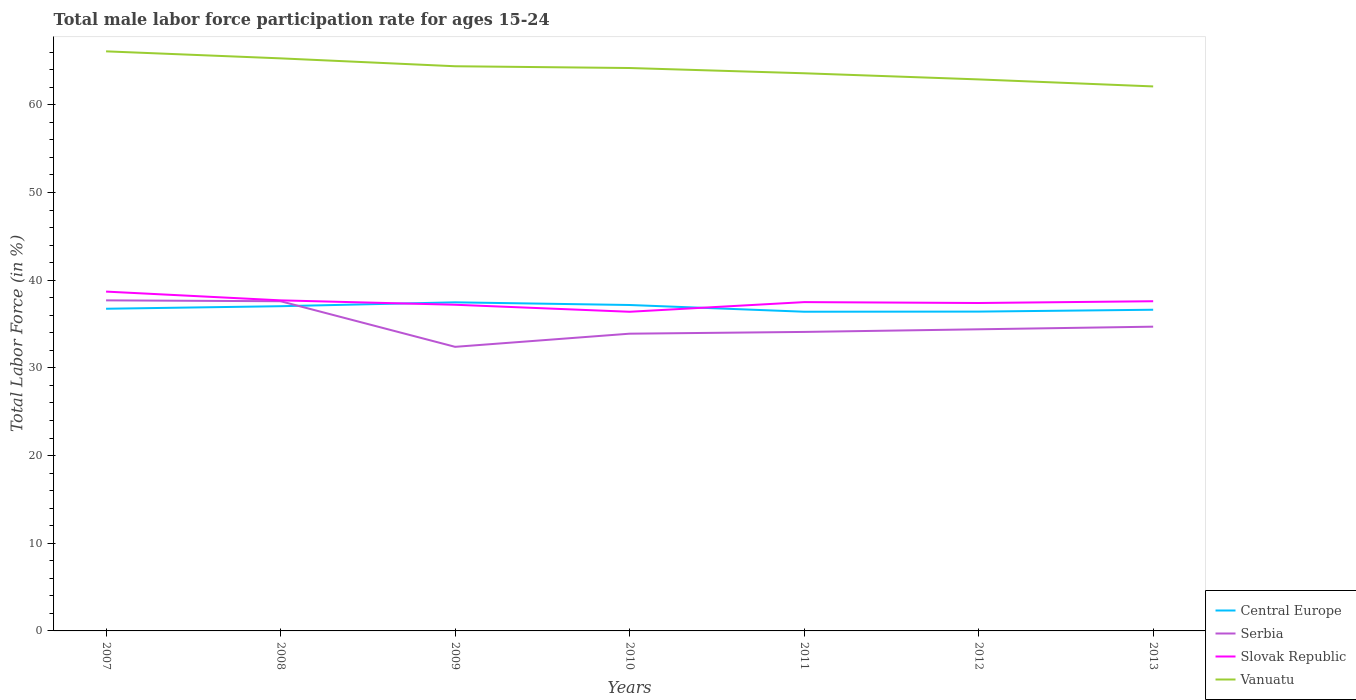How many different coloured lines are there?
Offer a very short reply. 4. Is the number of lines equal to the number of legend labels?
Offer a terse response. Yes. Across all years, what is the maximum male labor force participation rate in Slovak Republic?
Give a very brief answer. 36.4. In which year was the male labor force participation rate in Serbia maximum?
Keep it short and to the point. 2009. What is the total male labor force participation rate in Serbia in the graph?
Provide a short and direct response. 2.9. What is the difference between the highest and the second highest male labor force participation rate in Slovak Republic?
Provide a succinct answer. 2.3. Is the male labor force participation rate in Serbia strictly greater than the male labor force participation rate in Vanuatu over the years?
Your response must be concise. Yes. How many lines are there?
Offer a terse response. 4. How many years are there in the graph?
Provide a short and direct response. 7. What is the difference between two consecutive major ticks on the Y-axis?
Offer a terse response. 10. Are the values on the major ticks of Y-axis written in scientific E-notation?
Your response must be concise. No. Does the graph contain any zero values?
Your answer should be very brief. No. Does the graph contain grids?
Offer a terse response. No. How are the legend labels stacked?
Provide a short and direct response. Vertical. What is the title of the graph?
Your answer should be very brief. Total male labor force participation rate for ages 15-24. Does "Dominican Republic" appear as one of the legend labels in the graph?
Your answer should be very brief. No. What is the label or title of the X-axis?
Your response must be concise. Years. What is the label or title of the Y-axis?
Your answer should be very brief. Total Labor Force (in %). What is the Total Labor Force (in %) in Central Europe in 2007?
Your response must be concise. 36.74. What is the Total Labor Force (in %) of Serbia in 2007?
Offer a very short reply. 37.7. What is the Total Labor Force (in %) in Slovak Republic in 2007?
Make the answer very short. 38.7. What is the Total Labor Force (in %) in Vanuatu in 2007?
Your response must be concise. 66.1. What is the Total Labor Force (in %) in Central Europe in 2008?
Your answer should be very brief. 37.03. What is the Total Labor Force (in %) of Serbia in 2008?
Your response must be concise. 37.6. What is the Total Labor Force (in %) of Slovak Republic in 2008?
Provide a succinct answer. 37.7. What is the Total Labor Force (in %) of Vanuatu in 2008?
Ensure brevity in your answer.  65.3. What is the Total Labor Force (in %) in Central Europe in 2009?
Offer a terse response. 37.48. What is the Total Labor Force (in %) of Serbia in 2009?
Offer a terse response. 32.4. What is the Total Labor Force (in %) of Slovak Republic in 2009?
Your answer should be compact. 37.2. What is the Total Labor Force (in %) of Vanuatu in 2009?
Provide a succinct answer. 64.4. What is the Total Labor Force (in %) in Central Europe in 2010?
Offer a terse response. 37.17. What is the Total Labor Force (in %) in Serbia in 2010?
Offer a very short reply. 33.9. What is the Total Labor Force (in %) of Slovak Republic in 2010?
Keep it short and to the point. 36.4. What is the Total Labor Force (in %) in Vanuatu in 2010?
Provide a succinct answer. 64.2. What is the Total Labor Force (in %) in Central Europe in 2011?
Keep it short and to the point. 36.4. What is the Total Labor Force (in %) in Serbia in 2011?
Offer a very short reply. 34.1. What is the Total Labor Force (in %) in Slovak Republic in 2011?
Provide a succinct answer. 37.5. What is the Total Labor Force (in %) of Vanuatu in 2011?
Provide a succinct answer. 63.6. What is the Total Labor Force (in %) in Central Europe in 2012?
Give a very brief answer. 36.42. What is the Total Labor Force (in %) in Serbia in 2012?
Provide a short and direct response. 34.4. What is the Total Labor Force (in %) in Slovak Republic in 2012?
Provide a short and direct response. 37.4. What is the Total Labor Force (in %) in Vanuatu in 2012?
Make the answer very short. 62.9. What is the Total Labor Force (in %) of Central Europe in 2013?
Keep it short and to the point. 36.63. What is the Total Labor Force (in %) in Serbia in 2013?
Offer a terse response. 34.7. What is the Total Labor Force (in %) of Slovak Republic in 2013?
Your answer should be very brief. 37.6. What is the Total Labor Force (in %) of Vanuatu in 2013?
Keep it short and to the point. 62.1. Across all years, what is the maximum Total Labor Force (in %) in Central Europe?
Provide a short and direct response. 37.48. Across all years, what is the maximum Total Labor Force (in %) of Serbia?
Make the answer very short. 37.7. Across all years, what is the maximum Total Labor Force (in %) in Slovak Republic?
Make the answer very short. 38.7. Across all years, what is the maximum Total Labor Force (in %) in Vanuatu?
Your answer should be very brief. 66.1. Across all years, what is the minimum Total Labor Force (in %) in Central Europe?
Provide a succinct answer. 36.4. Across all years, what is the minimum Total Labor Force (in %) in Serbia?
Provide a succinct answer. 32.4. Across all years, what is the minimum Total Labor Force (in %) of Slovak Republic?
Offer a very short reply. 36.4. Across all years, what is the minimum Total Labor Force (in %) of Vanuatu?
Provide a succinct answer. 62.1. What is the total Total Labor Force (in %) of Central Europe in the graph?
Offer a terse response. 257.88. What is the total Total Labor Force (in %) in Serbia in the graph?
Make the answer very short. 244.8. What is the total Total Labor Force (in %) of Slovak Republic in the graph?
Provide a short and direct response. 262.5. What is the total Total Labor Force (in %) in Vanuatu in the graph?
Keep it short and to the point. 448.6. What is the difference between the Total Labor Force (in %) of Central Europe in 2007 and that in 2008?
Ensure brevity in your answer.  -0.29. What is the difference between the Total Labor Force (in %) in Slovak Republic in 2007 and that in 2008?
Give a very brief answer. 1. What is the difference between the Total Labor Force (in %) in Vanuatu in 2007 and that in 2008?
Provide a succinct answer. 0.8. What is the difference between the Total Labor Force (in %) in Central Europe in 2007 and that in 2009?
Your response must be concise. -0.73. What is the difference between the Total Labor Force (in %) of Serbia in 2007 and that in 2009?
Offer a very short reply. 5.3. What is the difference between the Total Labor Force (in %) in Slovak Republic in 2007 and that in 2009?
Ensure brevity in your answer.  1.5. What is the difference between the Total Labor Force (in %) in Central Europe in 2007 and that in 2010?
Your answer should be compact. -0.43. What is the difference between the Total Labor Force (in %) of Slovak Republic in 2007 and that in 2010?
Provide a succinct answer. 2.3. What is the difference between the Total Labor Force (in %) in Central Europe in 2007 and that in 2011?
Keep it short and to the point. 0.34. What is the difference between the Total Labor Force (in %) in Vanuatu in 2007 and that in 2011?
Your response must be concise. 2.5. What is the difference between the Total Labor Force (in %) in Central Europe in 2007 and that in 2012?
Keep it short and to the point. 0.32. What is the difference between the Total Labor Force (in %) in Vanuatu in 2007 and that in 2012?
Provide a succinct answer. 3.2. What is the difference between the Total Labor Force (in %) of Central Europe in 2007 and that in 2013?
Your response must be concise. 0.11. What is the difference between the Total Labor Force (in %) in Central Europe in 2008 and that in 2009?
Your answer should be compact. -0.44. What is the difference between the Total Labor Force (in %) of Slovak Republic in 2008 and that in 2009?
Your answer should be very brief. 0.5. What is the difference between the Total Labor Force (in %) in Vanuatu in 2008 and that in 2009?
Provide a short and direct response. 0.9. What is the difference between the Total Labor Force (in %) of Central Europe in 2008 and that in 2010?
Your response must be concise. -0.14. What is the difference between the Total Labor Force (in %) in Serbia in 2008 and that in 2010?
Offer a very short reply. 3.7. What is the difference between the Total Labor Force (in %) of Slovak Republic in 2008 and that in 2010?
Make the answer very short. 1.3. What is the difference between the Total Labor Force (in %) in Central Europe in 2008 and that in 2011?
Provide a succinct answer. 0.63. What is the difference between the Total Labor Force (in %) of Serbia in 2008 and that in 2011?
Provide a short and direct response. 3.5. What is the difference between the Total Labor Force (in %) of Slovak Republic in 2008 and that in 2011?
Ensure brevity in your answer.  0.2. What is the difference between the Total Labor Force (in %) of Vanuatu in 2008 and that in 2011?
Your response must be concise. 1.7. What is the difference between the Total Labor Force (in %) in Central Europe in 2008 and that in 2012?
Provide a succinct answer. 0.61. What is the difference between the Total Labor Force (in %) in Serbia in 2008 and that in 2012?
Offer a terse response. 3.2. What is the difference between the Total Labor Force (in %) in Central Europe in 2008 and that in 2013?
Make the answer very short. 0.4. What is the difference between the Total Labor Force (in %) in Serbia in 2008 and that in 2013?
Provide a succinct answer. 2.9. What is the difference between the Total Labor Force (in %) in Vanuatu in 2008 and that in 2013?
Give a very brief answer. 3.2. What is the difference between the Total Labor Force (in %) in Central Europe in 2009 and that in 2010?
Offer a terse response. 0.31. What is the difference between the Total Labor Force (in %) of Vanuatu in 2009 and that in 2010?
Your answer should be compact. 0.2. What is the difference between the Total Labor Force (in %) of Central Europe in 2009 and that in 2011?
Give a very brief answer. 1.07. What is the difference between the Total Labor Force (in %) in Slovak Republic in 2009 and that in 2011?
Your answer should be very brief. -0.3. What is the difference between the Total Labor Force (in %) of Vanuatu in 2009 and that in 2011?
Your response must be concise. 0.8. What is the difference between the Total Labor Force (in %) of Central Europe in 2009 and that in 2012?
Your answer should be compact. 1.06. What is the difference between the Total Labor Force (in %) of Central Europe in 2009 and that in 2013?
Your answer should be very brief. 0.84. What is the difference between the Total Labor Force (in %) in Serbia in 2009 and that in 2013?
Provide a succinct answer. -2.3. What is the difference between the Total Labor Force (in %) in Slovak Republic in 2009 and that in 2013?
Your response must be concise. -0.4. What is the difference between the Total Labor Force (in %) in Central Europe in 2010 and that in 2011?
Your answer should be compact. 0.77. What is the difference between the Total Labor Force (in %) in Serbia in 2010 and that in 2011?
Offer a very short reply. -0.2. What is the difference between the Total Labor Force (in %) in Central Europe in 2010 and that in 2012?
Your answer should be very brief. 0.75. What is the difference between the Total Labor Force (in %) in Serbia in 2010 and that in 2012?
Keep it short and to the point. -0.5. What is the difference between the Total Labor Force (in %) in Central Europe in 2010 and that in 2013?
Your response must be concise. 0.54. What is the difference between the Total Labor Force (in %) in Serbia in 2010 and that in 2013?
Provide a succinct answer. -0.8. What is the difference between the Total Labor Force (in %) of Vanuatu in 2010 and that in 2013?
Give a very brief answer. 2.1. What is the difference between the Total Labor Force (in %) of Central Europe in 2011 and that in 2012?
Keep it short and to the point. -0.01. What is the difference between the Total Labor Force (in %) in Serbia in 2011 and that in 2012?
Make the answer very short. -0.3. What is the difference between the Total Labor Force (in %) in Slovak Republic in 2011 and that in 2012?
Ensure brevity in your answer.  0.1. What is the difference between the Total Labor Force (in %) of Vanuatu in 2011 and that in 2012?
Ensure brevity in your answer.  0.7. What is the difference between the Total Labor Force (in %) of Central Europe in 2011 and that in 2013?
Offer a terse response. -0.23. What is the difference between the Total Labor Force (in %) of Central Europe in 2012 and that in 2013?
Offer a very short reply. -0.21. What is the difference between the Total Labor Force (in %) in Slovak Republic in 2012 and that in 2013?
Offer a very short reply. -0.2. What is the difference between the Total Labor Force (in %) in Vanuatu in 2012 and that in 2013?
Offer a terse response. 0.8. What is the difference between the Total Labor Force (in %) in Central Europe in 2007 and the Total Labor Force (in %) in Serbia in 2008?
Ensure brevity in your answer.  -0.86. What is the difference between the Total Labor Force (in %) in Central Europe in 2007 and the Total Labor Force (in %) in Slovak Republic in 2008?
Your answer should be very brief. -0.96. What is the difference between the Total Labor Force (in %) in Central Europe in 2007 and the Total Labor Force (in %) in Vanuatu in 2008?
Keep it short and to the point. -28.56. What is the difference between the Total Labor Force (in %) in Serbia in 2007 and the Total Labor Force (in %) in Vanuatu in 2008?
Provide a succinct answer. -27.6. What is the difference between the Total Labor Force (in %) in Slovak Republic in 2007 and the Total Labor Force (in %) in Vanuatu in 2008?
Make the answer very short. -26.6. What is the difference between the Total Labor Force (in %) in Central Europe in 2007 and the Total Labor Force (in %) in Serbia in 2009?
Keep it short and to the point. 4.34. What is the difference between the Total Labor Force (in %) of Central Europe in 2007 and the Total Labor Force (in %) of Slovak Republic in 2009?
Give a very brief answer. -0.46. What is the difference between the Total Labor Force (in %) in Central Europe in 2007 and the Total Labor Force (in %) in Vanuatu in 2009?
Offer a terse response. -27.66. What is the difference between the Total Labor Force (in %) of Serbia in 2007 and the Total Labor Force (in %) of Slovak Republic in 2009?
Keep it short and to the point. 0.5. What is the difference between the Total Labor Force (in %) of Serbia in 2007 and the Total Labor Force (in %) of Vanuatu in 2009?
Offer a very short reply. -26.7. What is the difference between the Total Labor Force (in %) in Slovak Republic in 2007 and the Total Labor Force (in %) in Vanuatu in 2009?
Offer a terse response. -25.7. What is the difference between the Total Labor Force (in %) of Central Europe in 2007 and the Total Labor Force (in %) of Serbia in 2010?
Your answer should be very brief. 2.84. What is the difference between the Total Labor Force (in %) in Central Europe in 2007 and the Total Labor Force (in %) in Slovak Republic in 2010?
Give a very brief answer. 0.34. What is the difference between the Total Labor Force (in %) of Central Europe in 2007 and the Total Labor Force (in %) of Vanuatu in 2010?
Provide a succinct answer. -27.46. What is the difference between the Total Labor Force (in %) in Serbia in 2007 and the Total Labor Force (in %) in Slovak Republic in 2010?
Provide a succinct answer. 1.3. What is the difference between the Total Labor Force (in %) of Serbia in 2007 and the Total Labor Force (in %) of Vanuatu in 2010?
Offer a very short reply. -26.5. What is the difference between the Total Labor Force (in %) of Slovak Republic in 2007 and the Total Labor Force (in %) of Vanuatu in 2010?
Ensure brevity in your answer.  -25.5. What is the difference between the Total Labor Force (in %) of Central Europe in 2007 and the Total Labor Force (in %) of Serbia in 2011?
Give a very brief answer. 2.64. What is the difference between the Total Labor Force (in %) of Central Europe in 2007 and the Total Labor Force (in %) of Slovak Republic in 2011?
Make the answer very short. -0.76. What is the difference between the Total Labor Force (in %) in Central Europe in 2007 and the Total Labor Force (in %) in Vanuatu in 2011?
Your answer should be very brief. -26.86. What is the difference between the Total Labor Force (in %) in Serbia in 2007 and the Total Labor Force (in %) in Vanuatu in 2011?
Provide a short and direct response. -25.9. What is the difference between the Total Labor Force (in %) in Slovak Republic in 2007 and the Total Labor Force (in %) in Vanuatu in 2011?
Offer a very short reply. -24.9. What is the difference between the Total Labor Force (in %) of Central Europe in 2007 and the Total Labor Force (in %) of Serbia in 2012?
Your response must be concise. 2.34. What is the difference between the Total Labor Force (in %) of Central Europe in 2007 and the Total Labor Force (in %) of Slovak Republic in 2012?
Provide a succinct answer. -0.66. What is the difference between the Total Labor Force (in %) of Central Europe in 2007 and the Total Labor Force (in %) of Vanuatu in 2012?
Ensure brevity in your answer.  -26.16. What is the difference between the Total Labor Force (in %) of Serbia in 2007 and the Total Labor Force (in %) of Vanuatu in 2012?
Give a very brief answer. -25.2. What is the difference between the Total Labor Force (in %) in Slovak Republic in 2007 and the Total Labor Force (in %) in Vanuatu in 2012?
Offer a terse response. -24.2. What is the difference between the Total Labor Force (in %) in Central Europe in 2007 and the Total Labor Force (in %) in Serbia in 2013?
Provide a short and direct response. 2.04. What is the difference between the Total Labor Force (in %) of Central Europe in 2007 and the Total Labor Force (in %) of Slovak Republic in 2013?
Make the answer very short. -0.86. What is the difference between the Total Labor Force (in %) of Central Europe in 2007 and the Total Labor Force (in %) of Vanuatu in 2013?
Offer a terse response. -25.36. What is the difference between the Total Labor Force (in %) in Serbia in 2007 and the Total Labor Force (in %) in Slovak Republic in 2013?
Keep it short and to the point. 0.1. What is the difference between the Total Labor Force (in %) in Serbia in 2007 and the Total Labor Force (in %) in Vanuatu in 2013?
Keep it short and to the point. -24.4. What is the difference between the Total Labor Force (in %) in Slovak Republic in 2007 and the Total Labor Force (in %) in Vanuatu in 2013?
Provide a short and direct response. -23.4. What is the difference between the Total Labor Force (in %) of Central Europe in 2008 and the Total Labor Force (in %) of Serbia in 2009?
Offer a very short reply. 4.63. What is the difference between the Total Labor Force (in %) in Central Europe in 2008 and the Total Labor Force (in %) in Slovak Republic in 2009?
Provide a short and direct response. -0.17. What is the difference between the Total Labor Force (in %) of Central Europe in 2008 and the Total Labor Force (in %) of Vanuatu in 2009?
Offer a terse response. -27.37. What is the difference between the Total Labor Force (in %) in Serbia in 2008 and the Total Labor Force (in %) in Slovak Republic in 2009?
Make the answer very short. 0.4. What is the difference between the Total Labor Force (in %) in Serbia in 2008 and the Total Labor Force (in %) in Vanuatu in 2009?
Your answer should be very brief. -26.8. What is the difference between the Total Labor Force (in %) in Slovak Republic in 2008 and the Total Labor Force (in %) in Vanuatu in 2009?
Your response must be concise. -26.7. What is the difference between the Total Labor Force (in %) in Central Europe in 2008 and the Total Labor Force (in %) in Serbia in 2010?
Offer a very short reply. 3.13. What is the difference between the Total Labor Force (in %) in Central Europe in 2008 and the Total Labor Force (in %) in Slovak Republic in 2010?
Offer a terse response. 0.63. What is the difference between the Total Labor Force (in %) of Central Europe in 2008 and the Total Labor Force (in %) of Vanuatu in 2010?
Your answer should be very brief. -27.17. What is the difference between the Total Labor Force (in %) of Serbia in 2008 and the Total Labor Force (in %) of Vanuatu in 2010?
Provide a short and direct response. -26.6. What is the difference between the Total Labor Force (in %) of Slovak Republic in 2008 and the Total Labor Force (in %) of Vanuatu in 2010?
Keep it short and to the point. -26.5. What is the difference between the Total Labor Force (in %) in Central Europe in 2008 and the Total Labor Force (in %) in Serbia in 2011?
Your answer should be very brief. 2.93. What is the difference between the Total Labor Force (in %) of Central Europe in 2008 and the Total Labor Force (in %) of Slovak Republic in 2011?
Ensure brevity in your answer.  -0.47. What is the difference between the Total Labor Force (in %) in Central Europe in 2008 and the Total Labor Force (in %) in Vanuatu in 2011?
Your response must be concise. -26.57. What is the difference between the Total Labor Force (in %) of Serbia in 2008 and the Total Labor Force (in %) of Vanuatu in 2011?
Ensure brevity in your answer.  -26. What is the difference between the Total Labor Force (in %) in Slovak Republic in 2008 and the Total Labor Force (in %) in Vanuatu in 2011?
Make the answer very short. -25.9. What is the difference between the Total Labor Force (in %) of Central Europe in 2008 and the Total Labor Force (in %) of Serbia in 2012?
Keep it short and to the point. 2.63. What is the difference between the Total Labor Force (in %) of Central Europe in 2008 and the Total Labor Force (in %) of Slovak Republic in 2012?
Offer a terse response. -0.37. What is the difference between the Total Labor Force (in %) in Central Europe in 2008 and the Total Labor Force (in %) in Vanuatu in 2012?
Provide a short and direct response. -25.87. What is the difference between the Total Labor Force (in %) in Serbia in 2008 and the Total Labor Force (in %) in Vanuatu in 2012?
Your answer should be compact. -25.3. What is the difference between the Total Labor Force (in %) in Slovak Republic in 2008 and the Total Labor Force (in %) in Vanuatu in 2012?
Give a very brief answer. -25.2. What is the difference between the Total Labor Force (in %) in Central Europe in 2008 and the Total Labor Force (in %) in Serbia in 2013?
Provide a short and direct response. 2.33. What is the difference between the Total Labor Force (in %) in Central Europe in 2008 and the Total Labor Force (in %) in Slovak Republic in 2013?
Keep it short and to the point. -0.57. What is the difference between the Total Labor Force (in %) of Central Europe in 2008 and the Total Labor Force (in %) of Vanuatu in 2013?
Provide a succinct answer. -25.07. What is the difference between the Total Labor Force (in %) in Serbia in 2008 and the Total Labor Force (in %) in Slovak Republic in 2013?
Keep it short and to the point. 0. What is the difference between the Total Labor Force (in %) in Serbia in 2008 and the Total Labor Force (in %) in Vanuatu in 2013?
Your answer should be compact. -24.5. What is the difference between the Total Labor Force (in %) in Slovak Republic in 2008 and the Total Labor Force (in %) in Vanuatu in 2013?
Ensure brevity in your answer.  -24.4. What is the difference between the Total Labor Force (in %) in Central Europe in 2009 and the Total Labor Force (in %) in Serbia in 2010?
Ensure brevity in your answer.  3.58. What is the difference between the Total Labor Force (in %) of Central Europe in 2009 and the Total Labor Force (in %) of Slovak Republic in 2010?
Offer a very short reply. 1.08. What is the difference between the Total Labor Force (in %) of Central Europe in 2009 and the Total Labor Force (in %) of Vanuatu in 2010?
Keep it short and to the point. -26.72. What is the difference between the Total Labor Force (in %) in Serbia in 2009 and the Total Labor Force (in %) in Vanuatu in 2010?
Give a very brief answer. -31.8. What is the difference between the Total Labor Force (in %) of Slovak Republic in 2009 and the Total Labor Force (in %) of Vanuatu in 2010?
Your response must be concise. -27. What is the difference between the Total Labor Force (in %) in Central Europe in 2009 and the Total Labor Force (in %) in Serbia in 2011?
Make the answer very short. 3.38. What is the difference between the Total Labor Force (in %) in Central Europe in 2009 and the Total Labor Force (in %) in Slovak Republic in 2011?
Offer a terse response. -0.02. What is the difference between the Total Labor Force (in %) in Central Europe in 2009 and the Total Labor Force (in %) in Vanuatu in 2011?
Your answer should be very brief. -26.12. What is the difference between the Total Labor Force (in %) of Serbia in 2009 and the Total Labor Force (in %) of Slovak Republic in 2011?
Give a very brief answer. -5.1. What is the difference between the Total Labor Force (in %) of Serbia in 2009 and the Total Labor Force (in %) of Vanuatu in 2011?
Offer a terse response. -31.2. What is the difference between the Total Labor Force (in %) of Slovak Republic in 2009 and the Total Labor Force (in %) of Vanuatu in 2011?
Your response must be concise. -26.4. What is the difference between the Total Labor Force (in %) of Central Europe in 2009 and the Total Labor Force (in %) of Serbia in 2012?
Make the answer very short. 3.08. What is the difference between the Total Labor Force (in %) of Central Europe in 2009 and the Total Labor Force (in %) of Slovak Republic in 2012?
Your response must be concise. 0.08. What is the difference between the Total Labor Force (in %) of Central Europe in 2009 and the Total Labor Force (in %) of Vanuatu in 2012?
Offer a very short reply. -25.42. What is the difference between the Total Labor Force (in %) in Serbia in 2009 and the Total Labor Force (in %) in Slovak Republic in 2012?
Make the answer very short. -5. What is the difference between the Total Labor Force (in %) of Serbia in 2009 and the Total Labor Force (in %) of Vanuatu in 2012?
Keep it short and to the point. -30.5. What is the difference between the Total Labor Force (in %) in Slovak Republic in 2009 and the Total Labor Force (in %) in Vanuatu in 2012?
Your answer should be very brief. -25.7. What is the difference between the Total Labor Force (in %) in Central Europe in 2009 and the Total Labor Force (in %) in Serbia in 2013?
Offer a terse response. 2.78. What is the difference between the Total Labor Force (in %) of Central Europe in 2009 and the Total Labor Force (in %) of Slovak Republic in 2013?
Make the answer very short. -0.12. What is the difference between the Total Labor Force (in %) of Central Europe in 2009 and the Total Labor Force (in %) of Vanuatu in 2013?
Provide a short and direct response. -24.62. What is the difference between the Total Labor Force (in %) in Serbia in 2009 and the Total Labor Force (in %) in Slovak Republic in 2013?
Offer a very short reply. -5.2. What is the difference between the Total Labor Force (in %) of Serbia in 2009 and the Total Labor Force (in %) of Vanuatu in 2013?
Your answer should be compact. -29.7. What is the difference between the Total Labor Force (in %) of Slovak Republic in 2009 and the Total Labor Force (in %) of Vanuatu in 2013?
Offer a terse response. -24.9. What is the difference between the Total Labor Force (in %) of Central Europe in 2010 and the Total Labor Force (in %) of Serbia in 2011?
Your answer should be compact. 3.07. What is the difference between the Total Labor Force (in %) of Central Europe in 2010 and the Total Labor Force (in %) of Slovak Republic in 2011?
Provide a succinct answer. -0.33. What is the difference between the Total Labor Force (in %) in Central Europe in 2010 and the Total Labor Force (in %) in Vanuatu in 2011?
Keep it short and to the point. -26.43. What is the difference between the Total Labor Force (in %) of Serbia in 2010 and the Total Labor Force (in %) of Slovak Republic in 2011?
Provide a short and direct response. -3.6. What is the difference between the Total Labor Force (in %) in Serbia in 2010 and the Total Labor Force (in %) in Vanuatu in 2011?
Offer a terse response. -29.7. What is the difference between the Total Labor Force (in %) of Slovak Republic in 2010 and the Total Labor Force (in %) of Vanuatu in 2011?
Ensure brevity in your answer.  -27.2. What is the difference between the Total Labor Force (in %) in Central Europe in 2010 and the Total Labor Force (in %) in Serbia in 2012?
Keep it short and to the point. 2.77. What is the difference between the Total Labor Force (in %) in Central Europe in 2010 and the Total Labor Force (in %) in Slovak Republic in 2012?
Make the answer very short. -0.23. What is the difference between the Total Labor Force (in %) of Central Europe in 2010 and the Total Labor Force (in %) of Vanuatu in 2012?
Give a very brief answer. -25.73. What is the difference between the Total Labor Force (in %) in Serbia in 2010 and the Total Labor Force (in %) in Slovak Republic in 2012?
Offer a terse response. -3.5. What is the difference between the Total Labor Force (in %) of Slovak Republic in 2010 and the Total Labor Force (in %) of Vanuatu in 2012?
Make the answer very short. -26.5. What is the difference between the Total Labor Force (in %) in Central Europe in 2010 and the Total Labor Force (in %) in Serbia in 2013?
Give a very brief answer. 2.47. What is the difference between the Total Labor Force (in %) in Central Europe in 2010 and the Total Labor Force (in %) in Slovak Republic in 2013?
Your answer should be compact. -0.43. What is the difference between the Total Labor Force (in %) in Central Europe in 2010 and the Total Labor Force (in %) in Vanuatu in 2013?
Give a very brief answer. -24.93. What is the difference between the Total Labor Force (in %) of Serbia in 2010 and the Total Labor Force (in %) of Slovak Republic in 2013?
Keep it short and to the point. -3.7. What is the difference between the Total Labor Force (in %) of Serbia in 2010 and the Total Labor Force (in %) of Vanuatu in 2013?
Give a very brief answer. -28.2. What is the difference between the Total Labor Force (in %) in Slovak Republic in 2010 and the Total Labor Force (in %) in Vanuatu in 2013?
Make the answer very short. -25.7. What is the difference between the Total Labor Force (in %) of Central Europe in 2011 and the Total Labor Force (in %) of Serbia in 2012?
Your answer should be very brief. 2. What is the difference between the Total Labor Force (in %) in Central Europe in 2011 and the Total Labor Force (in %) in Slovak Republic in 2012?
Your answer should be very brief. -1. What is the difference between the Total Labor Force (in %) of Central Europe in 2011 and the Total Labor Force (in %) of Vanuatu in 2012?
Your answer should be compact. -26.5. What is the difference between the Total Labor Force (in %) of Serbia in 2011 and the Total Labor Force (in %) of Slovak Republic in 2012?
Your response must be concise. -3.3. What is the difference between the Total Labor Force (in %) in Serbia in 2011 and the Total Labor Force (in %) in Vanuatu in 2012?
Offer a very short reply. -28.8. What is the difference between the Total Labor Force (in %) in Slovak Republic in 2011 and the Total Labor Force (in %) in Vanuatu in 2012?
Provide a short and direct response. -25.4. What is the difference between the Total Labor Force (in %) of Central Europe in 2011 and the Total Labor Force (in %) of Serbia in 2013?
Offer a terse response. 1.7. What is the difference between the Total Labor Force (in %) of Central Europe in 2011 and the Total Labor Force (in %) of Slovak Republic in 2013?
Offer a very short reply. -1.2. What is the difference between the Total Labor Force (in %) in Central Europe in 2011 and the Total Labor Force (in %) in Vanuatu in 2013?
Provide a succinct answer. -25.7. What is the difference between the Total Labor Force (in %) of Serbia in 2011 and the Total Labor Force (in %) of Slovak Republic in 2013?
Ensure brevity in your answer.  -3.5. What is the difference between the Total Labor Force (in %) of Slovak Republic in 2011 and the Total Labor Force (in %) of Vanuatu in 2013?
Provide a short and direct response. -24.6. What is the difference between the Total Labor Force (in %) in Central Europe in 2012 and the Total Labor Force (in %) in Serbia in 2013?
Keep it short and to the point. 1.72. What is the difference between the Total Labor Force (in %) of Central Europe in 2012 and the Total Labor Force (in %) of Slovak Republic in 2013?
Ensure brevity in your answer.  -1.18. What is the difference between the Total Labor Force (in %) in Central Europe in 2012 and the Total Labor Force (in %) in Vanuatu in 2013?
Make the answer very short. -25.68. What is the difference between the Total Labor Force (in %) of Serbia in 2012 and the Total Labor Force (in %) of Vanuatu in 2013?
Your answer should be very brief. -27.7. What is the difference between the Total Labor Force (in %) in Slovak Republic in 2012 and the Total Labor Force (in %) in Vanuatu in 2013?
Your answer should be very brief. -24.7. What is the average Total Labor Force (in %) in Central Europe per year?
Make the answer very short. 36.84. What is the average Total Labor Force (in %) of Serbia per year?
Keep it short and to the point. 34.97. What is the average Total Labor Force (in %) of Slovak Republic per year?
Ensure brevity in your answer.  37.5. What is the average Total Labor Force (in %) in Vanuatu per year?
Ensure brevity in your answer.  64.09. In the year 2007, what is the difference between the Total Labor Force (in %) in Central Europe and Total Labor Force (in %) in Serbia?
Your answer should be compact. -0.96. In the year 2007, what is the difference between the Total Labor Force (in %) in Central Europe and Total Labor Force (in %) in Slovak Republic?
Offer a very short reply. -1.96. In the year 2007, what is the difference between the Total Labor Force (in %) of Central Europe and Total Labor Force (in %) of Vanuatu?
Offer a very short reply. -29.36. In the year 2007, what is the difference between the Total Labor Force (in %) of Serbia and Total Labor Force (in %) of Vanuatu?
Offer a terse response. -28.4. In the year 2007, what is the difference between the Total Labor Force (in %) of Slovak Republic and Total Labor Force (in %) of Vanuatu?
Make the answer very short. -27.4. In the year 2008, what is the difference between the Total Labor Force (in %) in Central Europe and Total Labor Force (in %) in Serbia?
Ensure brevity in your answer.  -0.57. In the year 2008, what is the difference between the Total Labor Force (in %) of Central Europe and Total Labor Force (in %) of Slovak Republic?
Provide a succinct answer. -0.67. In the year 2008, what is the difference between the Total Labor Force (in %) of Central Europe and Total Labor Force (in %) of Vanuatu?
Provide a short and direct response. -28.27. In the year 2008, what is the difference between the Total Labor Force (in %) of Serbia and Total Labor Force (in %) of Vanuatu?
Make the answer very short. -27.7. In the year 2008, what is the difference between the Total Labor Force (in %) in Slovak Republic and Total Labor Force (in %) in Vanuatu?
Keep it short and to the point. -27.6. In the year 2009, what is the difference between the Total Labor Force (in %) in Central Europe and Total Labor Force (in %) in Serbia?
Your answer should be compact. 5.08. In the year 2009, what is the difference between the Total Labor Force (in %) in Central Europe and Total Labor Force (in %) in Slovak Republic?
Give a very brief answer. 0.28. In the year 2009, what is the difference between the Total Labor Force (in %) in Central Europe and Total Labor Force (in %) in Vanuatu?
Ensure brevity in your answer.  -26.92. In the year 2009, what is the difference between the Total Labor Force (in %) in Serbia and Total Labor Force (in %) in Slovak Republic?
Your answer should be very brief. -4.8. In the year 2009, what is the difference between the Total Labor Force (in %) in Serbia and Total Labor Force (in %) in Vanuatu?
Your answer should be compact. -32. In the year 2009, what is the difference between the Total Labor Force (in %) in Slovak Republic and Total Labor Force (in %) in Vanuatu?
Keep it short and to the point. -27.2. In the year 2010, what is the difference between the Total Labor Force (in %) of Central Europe and Total Labor Force (in %) of Serbia?
Your answer should be very brief. 3.27. In the year 2010, what is the difference between the Total Labor Force (in %) of Central Europe and Total Labor Force (in %) of Slovak Republic?
Offer a terse response. 0.77. In the year 2010, what is the difference between the Total Labor Force (in %) of Central Europe and Total Labor Force (in %) of Vanuatu?
Your response must be concise. -27.03. In the year 2010, what is the difference between the Total Labor Force (in %) of Serbia and Total Labor Force (in %) of Slovak Republic?
Offer a very short reply. -2.5. In the year 2010, what is the difference between the Total Labor Force (in %) in Serbia and Total Labor Force (in %) in Vanuatu?
Keep it short and to the point. -30.3. In the year 2010, what is the difference between the Total Labor Force (in %) in Slovak Republic and Total Labor Force (in %) in Vanuatu?
Make the answer very short. -27.8. In the year 2011, what is the difference between the Total Labor Force (in %) of Central Europe and Total Labor Force (in %) of Serbia?
Keep it short and to the point. 2.3. In the year 2011, what is the difference between the Total Labor Force (in %) of Central Europe and Total Labor Force (in %) of Slovak Republic?
Provide a succinct answer. -1.1. In the year 2011, what is the difference between the Total Labor Force (in %) of Central Europe and Total Labor Force (in %) of Vanuatu?
Keep it short and to the point. -27.2. In the year 2011, what is the difference between the Total Labor Force (in %) of Serbia and Total Labor Force (in %) of Vanuatu?
Your answer should be very brief. -29.5. In the year 2011, what is the difference between the Total Labor Force (in %) in Slovak Republic and Total Labor Force (in %) in Vanuatu?
Offer a terse response. -26.1. In the year 2012, what is the difference between the Total Labor Force (in %) in Central Europe and Total Labor Force (in %) in Serbia?
Keep it short and to the point. 2.02. In the year 2012, what is the difference between the Total Labor Force (in %) of Central Europe and Total Labor Force (in %) of Slovak Republic?
Your answer should be compact. -0.98. In the year 2012, what is the difference between the Total Labor Force (in %) of Central Europe and Total Labor Force (in %) of Vanuatu?
Keep it short and to the point. -26.48. In the year 2012, what is the difference between the Total Labor Force (in %) in Serbia and Total Labor Force (in %) in Slovak Republic?
Provide a succinct answer. -3. In the year 2012, what is the difference between the Total Labor Force (in %) of Serbia and Total Labor Force (in %) of Vanuatu?
Keep it short and to the point. -28.5. In the year 2012, what is the difference between the Total Labor Force (in %) in Slovak Republic and Total Labor Force (in %) in Vanuatu?
Your response must be concise. -25.5. In the year 2013, what is the difference between the Total Labor Force (in %) in Central Europe and Total Labor Force (in %) in Serbia?
Offer a very short reply. 1.93. In the year 2013, what is the difference between the Total Labor Force (in %) in Central Europe and Total Labor Force (in %) in Slovak Republic?
Offer a terse response. -0.97. In the year 2013, what is the difference between the Total Labor Force (in %) in Central Europe and Total Labor Force (in %) in Vanuatu?
Provide a succinct answer. -25.47. In the year 2013, what is the difference between the Total Labor Force (in %) of Serbia and Total Labor Force (in %) of Slovak Republic?
Make the answer very short. -2.9. In the year 2013, what is the difference between the Total Labor Force (in %) of Serbia and Total Labor Force (in %) of Vanuatu?
Offer a terse response. -27.4. In the year 2013, what is the difference between the Total Labor Force (in %) of Slovak Republic and Total Labor Force (in %) of Vanuatu?
Provide a succinct answer. -24.5. What is the ratio of the Total Labor Force (in %) of Slovak Republic in 2007 to that in 2008?
Keep it short and to the point. 1.03. What is the ratio of the Total Labor Force (in %) in Vanuatu in 2007 to that in 2008?
Your answer should be compact. 1.01. What is the ratio of the Total Labor Force (in %) in Central Europe in 2007 to that in 2009?
Ensure brevity in your answer.  0.98. What is the ratio of the Total Labor Force (in %) of Serbia in 2007 to that in 2009?
Your answer should be compact. 1.16. What is the ratio of the Total Labor Force (in %) of Slovak Republic in 2007 to that in 2009?
Provide a succinct answer. 1.04. What is the ratio of the Total Labor Force (in %) of Vanuatu in 2007 to that in 2009?
Provide a short and direct response. 1.03. What is the ratio of the Total Labor Force (in %) in Central Europe in 2007 to that in 2010?
Provide a succinct answer. 0.99. What is the ratio of the Total Labor Force (in %) of Serbia in 2007 to that in 2010?
Ensure brevity in your answer.  1.11. What is the ratio of the Total Labor Force (in %) in Slovak Republic in 2007 to that in 2010?
Your response must be concise. 1.06. What is the ratio of the Total Labor Force (in %) in Vanuatu in 2007 to that in 2010?
Give a very brief answer. 1.03. What is the ratio of the Total Labor Force (in %) in Central Europe in 2007 to that in 2011?
Ensure brevity in your answer.  1.01. What is the ratio of the Total Labor Force (in %) of Serbia in 2007 to that in 2011?
Offer a terse response. 1.11. What is the ratio of the Total Labor Force (in %) of Slovak Republic in 2007 to that in 2011?
Offer a very short reply. 1.03. What is the ratio of the Total Labor Force (in %) in Vanuatu in 2007 to that in 2011?
Keep it short and to the point. 1.04. What is the ratio of the Total Labor Force (in %) of Central Europe in 2007 to that in 2012?
Provide a short and direct response. 1.01. What is the ratio of the Total Labor Force (in %) of Serbia in 2007 to that in 2012?
Give a very brief answer. 1.1. What is the ratio of the Total Labor Force (in %) of Slovak Republic in 2007 to that in 2012?
Your answer should be compact. 1.03. What is the ratio of the Total Labor Force (in %) of Vanuatu in 2007 to that in 2012?
Make the answer very short. 1.05. What is the ratio of the Total Labor Force (in %) of Central Europe in 2007 to that in 2013?
Your answer should be very brief. 1. What is the ratio of the Total Labor Force (in %) of Serbia in 2007 to that in 2013?
Your response must be concise. 1.09. What is the ratio of the Total Labor Force (in %) in Slovak Republic in 2007 to that in 2013?
Make the answer very short. 1.03. What is the ratio of the Total Labor Force (in %) in Vanuatu in 2007 to that in 2013?
Offer a very short reply. 1.06. What is the ratio of the Total Labor Force (in %) of Serbia in 2008 to that in 2009?
Your answer should be very brief. 1.16. What is the ratio of the Total Labor Force (in %) in Slovak Republic in 2008 to that in 2009?
Your response must be concise. 1.01. What is the ratio of the Total Labor Force (in %) in Central Europe in 2008 to that in 2010?
Ensure brevity in your answer.  1. What is the ratio of the Total Labor Force (in %) of Serbia in 2008 to that in 2010?
Offer a terse response. 1.11. What is the ratio of the Total Labor Force (in %) of Slovak Republic in 2008 to that in 2010?
Provide a short and direct response. 1.04. What is the ratio of the Total Labor Force (in %) in Vanuatu in 2008 to that in 2010?
Offer a terse response. 1.02. What is the ratio of the Total Labor Force (in %) of Central Europe in 2008 to that in 2011?
Ensure brevity in your answer.  1.02. What is the ratio of the Total Labor Force (in %) of Serbia in 2008 to that in 2011?
Your response must be concise. 1.1. What is the ratio of the Total Labor Force (in %) in Vanuatu in 2008 to that in 2011?
Your answer should be compact. 1.03. What is the ratio of the Total Labor Force (in %) of Central Europe in 2008 to that in 2012?
Make the answer very short. 1.02. What is the ratio of the Total Labor Force (in %) of Serbia in 2008 to that in 2012?
Your answer should be compact. 1.09. What is the ratio of the Total Labor Force (in %) in Vanuatu in 2008 to that in 2012?
Your answer should be compact. 1.04. What is the ratio of the Total Labor Force (in %) in Central Europe in 2008 to that in 2013?
Give a very brief answer. 1.01. What is the ratio of the Total Labor Force (in %) of Serbia in 2008 to that in 2013?
Provide a succinct answer. 1.08. What is the ratio of the Total Labor Force (in %) of Slovak Republic in 2008 to that in 2013?
Keep it short and to the point. 1. What is the ratio of the Total Labor Force (in %) of Vanuatu in 2008 to that in 2013?
Offer a terse response. 1.05. What is the ratio of the Total Labor Force (in %) of Central Europe in 2009 to that in 2010?
Your response must be concise. 1.01. What is the ratio of the Total Labor Force (in %) of Serbia in 2009 to that in 2010?
Offer a terse response. 0.96. What is the ratio of the Total Labor Force (in %) of Vanuatu in 2009 to that in 2010?
Provide a succinct answer. 1. What is the ratio of the Total Labor Force (in %) in Central Europe in 2009 to that in 2011?
Your answer should be very brief. 1.03. What is the ratio of the Total Labor Force (in %) of Serbia in 2009 to that in 2011?
Give a very brief answer. 0.95. What is the ratio of the Total Labor Force (in %) of Slovak Republic in 2009 to that in 2011?
Give a very brief answer. 0.99. What is the ratio of the Total Labor Force (in %) of Vanuatu in 2009 to that in 2011?
Your answer should be compact. 1.01. What is the ratio of the Total Labor Force (in %) of Serbia in 2009 to that in 2012?
Make the answer very short. 0.94. What is the ratio of the Total Labor Force (in %) of Vanuatu in 2009 to that in 2012?
Give a very brief answer. 1.02. What is the ratio of the Total Labor Force (in %) in Central Europe in 2009 to that in 2013?
Your answer should be very brief. 1.02. What is the ratio of the Total Labor Force (in %) in Serbia in 2009 to that in 2013?
Your answer should be very brief. 0.93. What is the ratio of the Total Labor Force (in %) of Slovak Republic in 2009 to that in 2013?
Provide a succinct answer. 0.99. What is the ratio of the Total Labor Force (in %) of Vanuatu in 2009 to that in 2013?
Offer a terse response. 1.04. What is the ratio of the Total Labor Force (in %) of Central Europe in 2010 to that in 2011?
Offer a terse response. 1.02. What is the ratio of the Total Labor Force (in %) in Serbia in 2010 to that in 2011?
Provide a succinct answer. 0.99. What is the ratio of the Total Labor Force (in %) in Slovak Republic in 2010 to that in 2011?
Keep it short and to the point. 0.97. What is the ratio of the Total Labor Force (in %) of Vanuatu in 2010 to that in 2011?
Give a very brief answer. 1.01. What is the ratio of the Total Labor Force (in %) of Central Europe in 2010 to that in 2012?
Offer a terse response. 1.02. What is the ratio of the Total Labor Force (in %) of Serbia in 2010 to that in 2012?
Provide a short and direct response. 0.99. What is the ratio of the Total Labor Force (in %) of Slovak Republic in 2010 to that in 2012?
Offer a very short reply. 0.97. What is the ratio of the Total Labor Force (in %) in Vanuatu in 2010 to that in 2012?
Your answer should be compact. 1.02. What is the ratio of the Total Labor Force (in %) of Central Europe in 2010 to that in 2013?
Provide a succinct answer. 1.01. What is the ratio of the Total Labor Force (in %) in Serbia in 2010 to that in 2013?
Provide a succinct answer. 0.98. What is the ratio of the Total Labor Force (in %) of Slovak Republic in 2010 to that in 2013?
Provide a succinct answer. 0.97. What is the ratio of the Total Labor Force (in %) in Vanuatu in 2010 to that in 2013?
Give a very brief answer. 1.03. What is the ratio of the Total Labor Force (in %) of Central Europe in 2011 to that in 2012?
Keep it short and to the point. 1. What is the ratio of the Total Labor Force (in %) in Vanuatu in 2011 to that in 2012?
Ensure brevity in your answer.  1.01. What is the ratio of the Total Labor Force (in %) in Central Europe in 2011 to that in 2013?
Make the answer very short. 0.99. What is the ratio of the Total Labor Force (in %) of Serbia in 2011 to that in 2013?
Provide a succinct answer. 0.98. What is the ratio of the Total Labor Force (in %) of Slovak Republic in 2011 to that in 2013?
Provide a short and direct response. 1. What is the ratio of the Total Labor Force (in %) of Vanuatu in 2011 to that in 2013?
Ensure brevity in your answer.  1.02. What is the ratio of the Total Labor Force (in %) in Central Europe in 2012 to that in 2013?
Your response must be concise. 0.99. What is the ratio of the Total Labor Force (in %) in Serbia in 2012 to that in 2013?
Make the answer very short. 0.99. What is the ratio of the Total Labor Force (in %) in Vanuatu in 2012 to that in 2013?
Give a very brief answer. 1.01. What is the difference between the highest and the second highest Total Labor Force (in %) of Central Europe?
Offer a terse response. 0.31. What is the difference between the highest and the second highest Total Labor Force (in %) in Serbia?
Offer a very short reply. 0.1. What is the difference between the highest and the second highest Total Labor Force (in %) in Slovak Republic?
Ensure brevity in your answer.  1. What is the difference between the highest and the lowest Total Labor Force (in %) in Central Europe?
Provide a succinct answer. 1.07. 